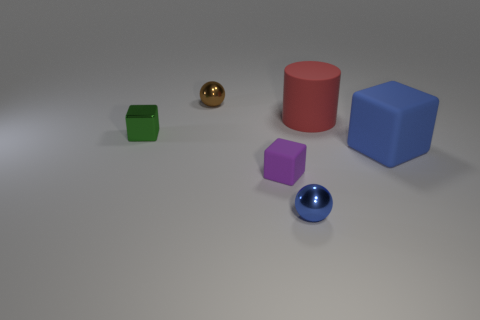There is another tiny thing that is the same shape as the tiny brown metallic thing; what is it made of?
Offer a terse response. Metal. What is the shape of the green object that is the same material as the blue ball?
Provide a short and direct response. Cube. How many other objects are there of the same color as the big cube?
Give a very brief answer. 1. Is the material of the large cylinder that is behind the metallic block the same as the big blue thing?
Give a very brief answer. Yes. What material is the block that is to the right of the small purple matte cube on the left side of the tiny blue thing made of?
Keep it short and to the point. Rubber. What number of large things are the same shape as the small rubber thing?
Your answer should be very brief. 1. What is the size of the metallic sphere on the left side of the small metallic ball in front of the tiny shiny ball behind the small blue metallic sphere?
Your answer should be compact. Small. How many brown things are either metal blocks or big rubber cubes?
Your response must be concise. 0. There is a tiny metal object on the right side of the tiny brown metallic object; does it have the same shape as the large red rubber object?
Offer a very short reply. No. Is the number of large matte things that are behind the tiny metallic cube greater than the number of purple metallic balls?
Your answer should be compact. Yes. 